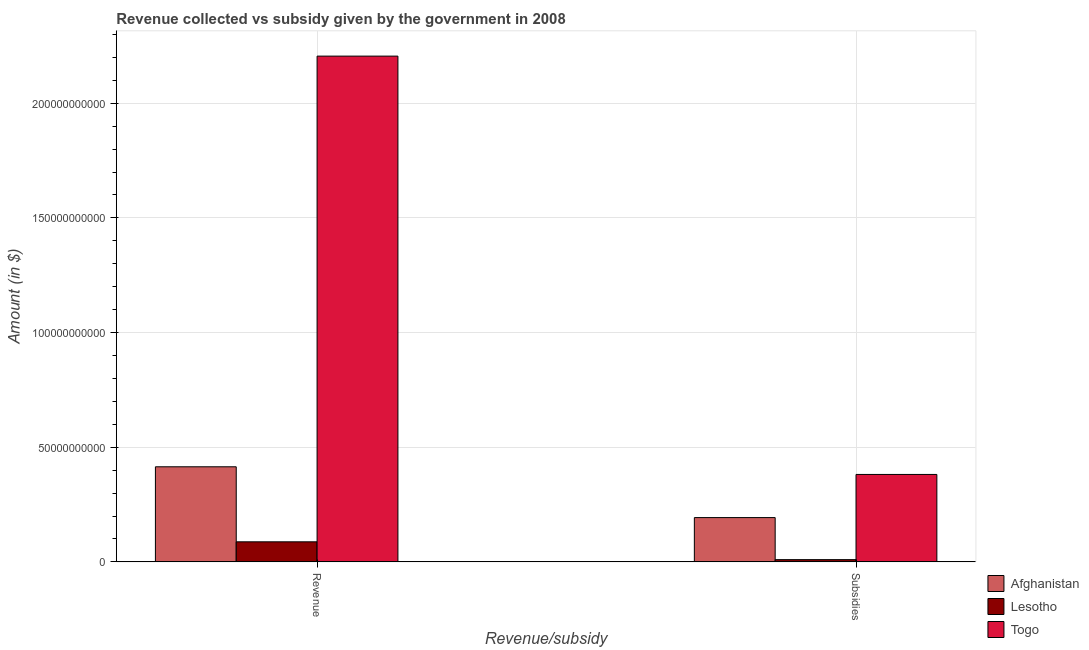How many groups of bars are there?
Provide a short and direct response. 2. How many bars are there on the 2nd tick from the left?
Your answer should be compact. 3. What is the label of the 2nd group of bars from the left?
Offer a terse response. Subsidies. What is the amount of subsidies given in Togo?
Your answer should be very brief. 3.81e+1. Across all countries, what is the maximum amount of revenue collected?
Ensure brevity in your answer.  2.21e+11. Across all countries, what is the minimum amount of revenue collected?
Provide a succinct answer. 8.76e+09. In which country was the amount of subsidies given maximum?
Provide a short and direct response. Togo. In which country was the amount of revenue collected minimum?
Keep it short and to the point. Lesotho. What is the total amount of revenue collected in the graph?
Your answer should be very brief. 2.71e+11. What is the difference between the amount of revenue collected in Togo and that in Afghanistan?
Give a very brief answer. 1.79e+11. What is the difference between the amount of subsidies given in Lesotho and the amount of revenue collected in Togo?
Offer a very short reply. -2.20e+11. What is the average amount of revenue collected per country?
Your response must be concise. 9.03e+1. What is the difference between the amount of subsidies given and amount of revenue collected in Lesotho?
Your answer should be very brief. -7.77e+09. What is the ratio of the amount of revenue collected in Togo to that in Afghanistan?
Offer a terse response. 5.32. In how many countries, is the amount of revenue collected greater than the average amount of revenue collected taken over all countries?
Ensure brevity in your answer.  1. What does the 1st bar from the left in Subsidies represents?
Your answer should be compact. Afghanistan. What does the 3rd bar from the right in Revenue represents?
Keep it short and to the point. Afghanistan. How many bars are there?
Offer a very short reply. 6. Are all the bars in the graph horizontal?
Offer a terse response. No. Does the graph contain any zero values?
Offer a very short reply. No. Does the graph contain grids?
Your answer should be very brief. Yes. How are the legend labels stacked?
Provide a short and direct response. Vertical. What is the title of the graph?
Offer a very short reply. Revenue collected vs subsidy given by the government in 2008. Does "Chad" appear as one of the legend labels in the graph?
Offer a terse response. No. What is the label or title of the X-axis?
Ensure brevity in your answer.  Revenue/subsidy. What is the label or title of the Y-axis?
Your answer should be very brief. Amount (in $). What is the Amount (in $) in Afghanistan in Revenue?
Offer a terse response. 4.15e+1. What is the Amount (in $) in Lesotho in Revenue?
Provide a succinct answer. 8.76e+09. What is the Amount (in $) in Togo in Revenue?
Offer a terse response. 2.21e+11. What is the Amount (in $) of Afghanistan in Subsidies?
Make the answer very short. 1.93e+1. What is the Amount (in $) in Lesotho in Subsidies?
Provide a succinct answer. 9.82e+08. What is the Amount (in $) of Togo in Subsidies?
Provide a succinct answer. 3.81e+1. Across all Revenue/subsidy, what is the maximum Amount (in $) of Afghanistan?
Your response must be concise. 4.15e+1. Across all Revenue/subsidy, what is the maximum Amount (in $) of Lesotho?
Give a very brief answer. 8.76e+09. Across all Revenue/subsidy, what is the maximum Amount (in $) in Togo?
Give a very brief answer. 2.21e+11. Across all Revenue/subsidy, what is the minimum Amount (in $) of Afghanistan?
Ensure brevity in your answer.  1.93e+1. Across all Revenue/subsidy, what is the minimum Amount (in $) in Lesotho?
Provide a succinct answer. 9.82e+08. Across all Revenue/subsidy, what is the minimum Amount (in $) of Togo?
Make the answer very short. 3.81e+1. What is the total Amount (in $) in Afghanistan in the graph?
Your response must be concise. 6.08e+1. What is the total Amount (in $) of Lesotho in the graph?
Offer a very short reply. 9.74e+09. What is the total Amount (in $) of Togo in the graph?
Give a very brief answer. 2.59e+11. What is the difference between the Amount (in $) of Afghanistan in Revenue and that in Subsidies?
Ensure brevity in your answer.  2.22e+1. What is the difference between the Amount (in $) of Lesotho in Revenue and that in Subsidies?
Give a very brief answer. 7.77e+09. What is the difference between the Amount (in $) of Togo in Revenue and that in Subsidies?
Give a very brief answer. 1.82e+11. What is the difference between the Amount (in $) in Afghanistan in Revenue and the Amount (in $) in Lesotho in Subsidies?
Give a very brief answer. 4.05e+1. What is the difference between the Amount (in $) of Afghanistan in Revenue and the Amount (in $) of Togo in Subsidies?
Ensure brevity in your answer.  3.34e+09. What is the difference between the Amount (in $) of Lesotho in Revenue and the Amount (in $) of Togo in Subsidies?
Keep it short and to the point. -2.94e+1. What is the average Amount (in $) of Afghanistan per Revenue/subsidy?
Your answer should be compact. 3.04e+1. What is the average Amount (in $) in Lesotho per Revenue/subsidy?
Your answer should be compact. 4.87e+09. What is the average Amount (in $) of Togo per Revenue/subsidy?
Give a very brief answer. 1.29e+11. What is the difference between the Amount (in $) in Afghanistan and Amount (in $) in Lesotho in Revenue?
Ensure brevity in your answer.  3.27e+1. What is the difference between the Amount (in $) of Afghanistan and Amount (in $) of Togo in Revenue?
Your response must be concise. -1.79e+11. What is the difference between the Amount (in $) in Lesotho and Amount (in $) in Togo in Revenue?
Your response must be concise. -2.12e+11. What is the difference between the Amount (in $) of Afghanistan and Amount (in $) of Lesotho in Subsidies?
Offer a very short reply. 1.83e+1. What is the difference between the Amount (in $) of Afghanistan and Amount (in $) of Togo in Subsidies?
Offer a very short reply. -1.88e+1. What is the difference between the Amount (in $) of Lesotho and Amount (in $) of Togo in Subsidies?
Make the answer very short. -3.72e+1. What is the ratio of the Amount (in $) in Afghanistan in Revenue to that in Subsidies?
Keep it short and to the point. 2.15. What is the ratio of the Amount (in $) of Lesotho in Revenue to that in Subsidies?
Offer a terse response. 8.92. What is the ratio of the Amount (in $) of Togo in Revenue to that in Subsidies?
Ensure brevity in your answer.  5.78. What is the difference between the highest and the second highest Amount (in $) of Afghanistan?
Provide a short and direct response. 2.22e+1. What is the difference between the highest and the second highest Amount (in $) in Lesotho?
Your response must be concise. 7.77e+09. What is the difference between the highest and the second highest Amount (in $) of Togo?
Your answer should be very brief. 1.82e+11. What is the difference between the highest and the lowest Amount (in $) in Afghanistan?
Keep it short and to the point. 2.22e+1. What is the difference between the highest and the lowest Amount (in $) in Lesotho?
Offer a terse response. 7.77e+09. What is the difference between the highest and the lowest Amount (in $) in Togo?
Provide a succinct answer. 1.82e+11. 